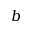Convert formula to latex. <formula><loc_0><loc_0><loc_500><loc_500>b</formula> 